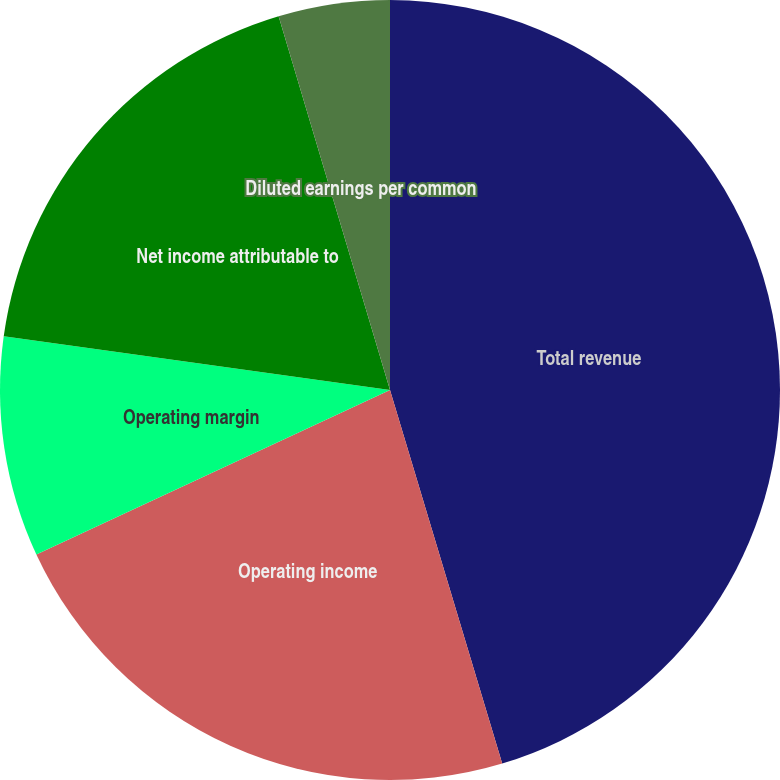<chart> <loc_0><loc_0><loc_500><loc_500><pie_chart><fcel>Total revenue<fcel>Operating income<fcel>Operating margin<fcel>Net income attributable to<fcel>Diluted earnings per common<nl><fcel>45.36%<fcel>22.72%<fcel>9.13%<fcel>18.19%<fcel>4.61%<nl></chart> 